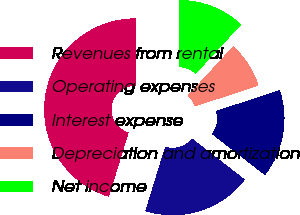Convert chart. <chart><loc_0><loc_0><loc_500><loc_500><pie_chart><fcel>Revenues from rental<fcel>Operating expenses<fcel>Interest expense<fcel>Depreciation and amortization<fcel>Net income<nl><fcel>45.29%<fcel>19.26%<fcel>15.54%<fcel>8.1%<fcel>11.82%<nl></chart> 